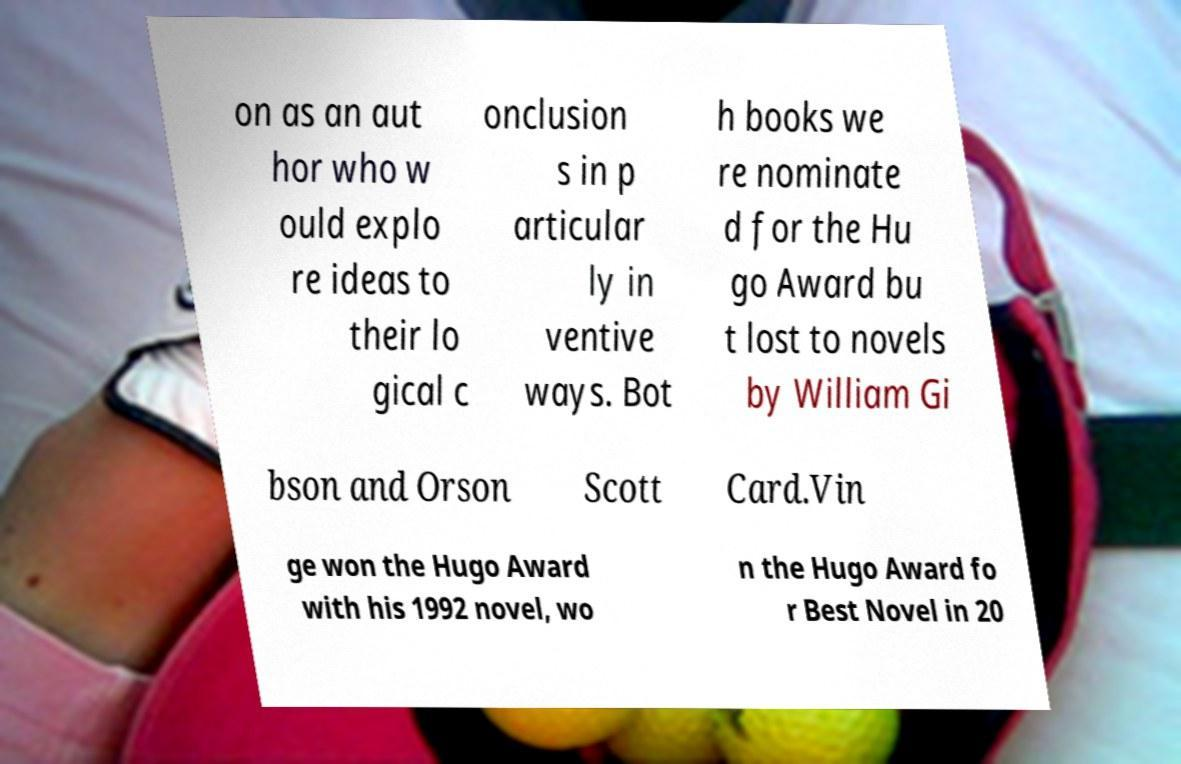What messages or text are displayed in this image? I need them in a readable, typed format. on as an aut hor who w ould explo re ideas to their lo gical c onclusion s in p articular ly in ventive ways. Bot h books we re nominate d for the Hu go Award bu t lost to novels by William Gi bson and Orson Scott Card.Vin ge won the Hugo Award with his 1992 novel, wo n the Hugo Award fo r Best Novel in 20 